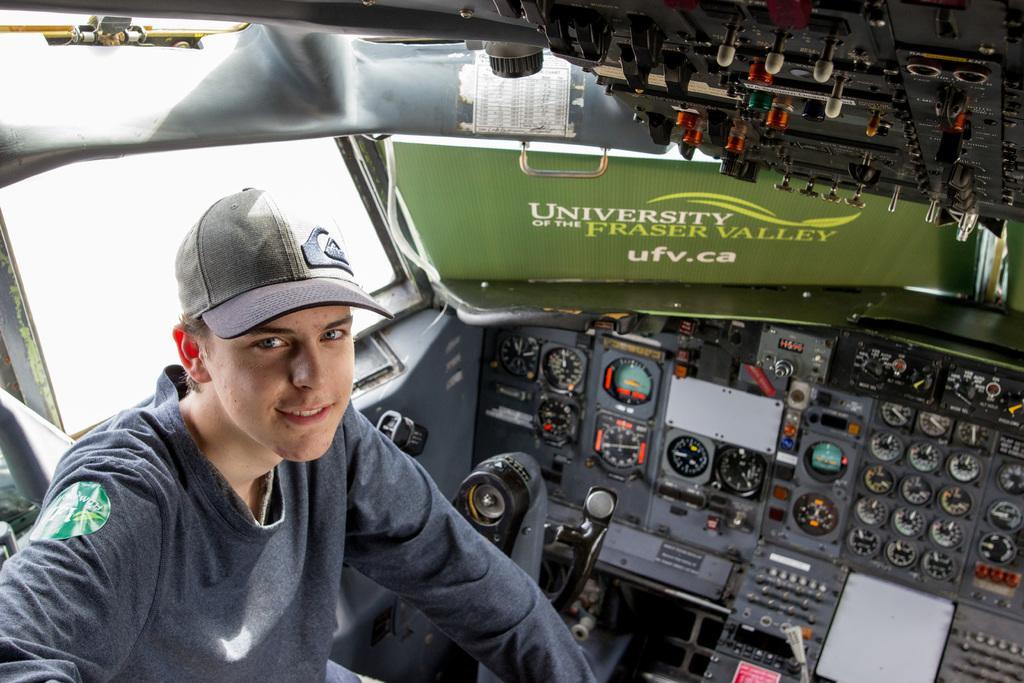Please provide a concise description of this image. In this picture there is a man who is wearing cap and t-shirt. He is sitting inside the plane. On the left there is a window. On the right I can see the speedometer, fuel meter and other meters. 